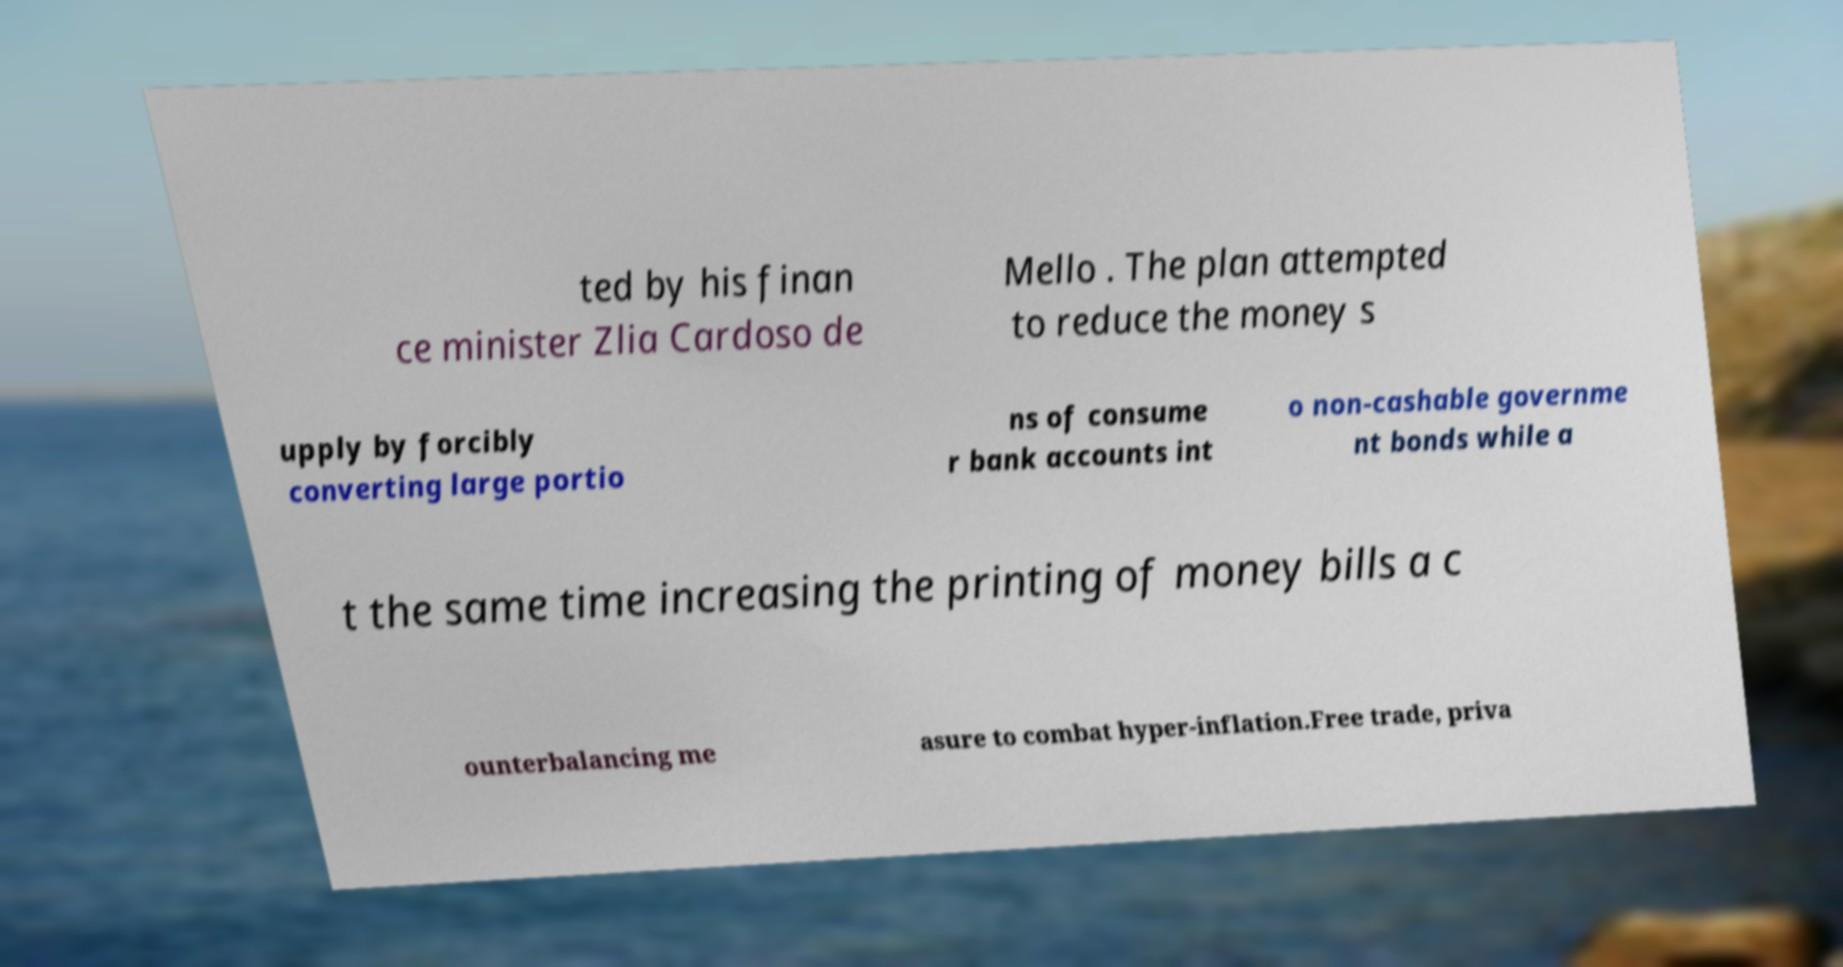Could you assist in decoding the text presented in this image and type it out clearly? ted by his finan ce minister Zlia Cardoso de Mello . The plan attempted to reduce the money s upply by forcibly converting large portio ns of consume r bank accounts int o non-cashable governme nt bonds while a t the same time increasing the printing of money bills a c ounterbalancing me asure to combat hyper-inflation.Free trade, priva 